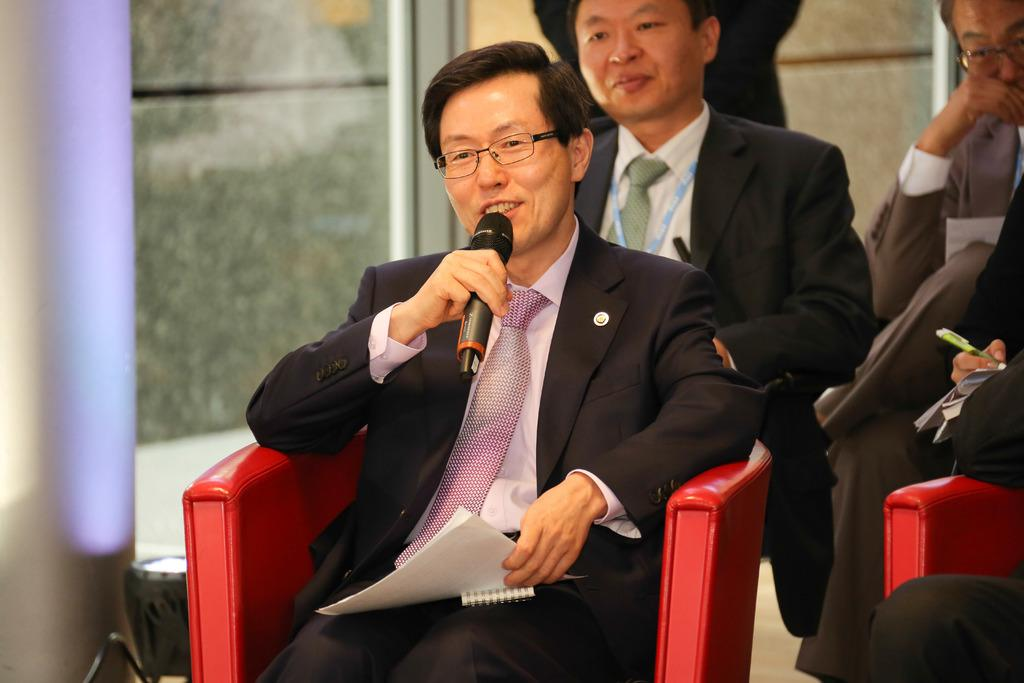What is the man in the image doing? The man is sitting on a chair in the image. Are there any other people in the image? Yes, there are people standing behind the man in the image. What is the man in front holding in his hand? The man in front is holding a microphone in his hand. What type of truck can be seen in the image? There is no truck present in the image. What is the man's interest in the image? The provided facts do not mention the man's interests, so we cannot determine his interest from the image. 